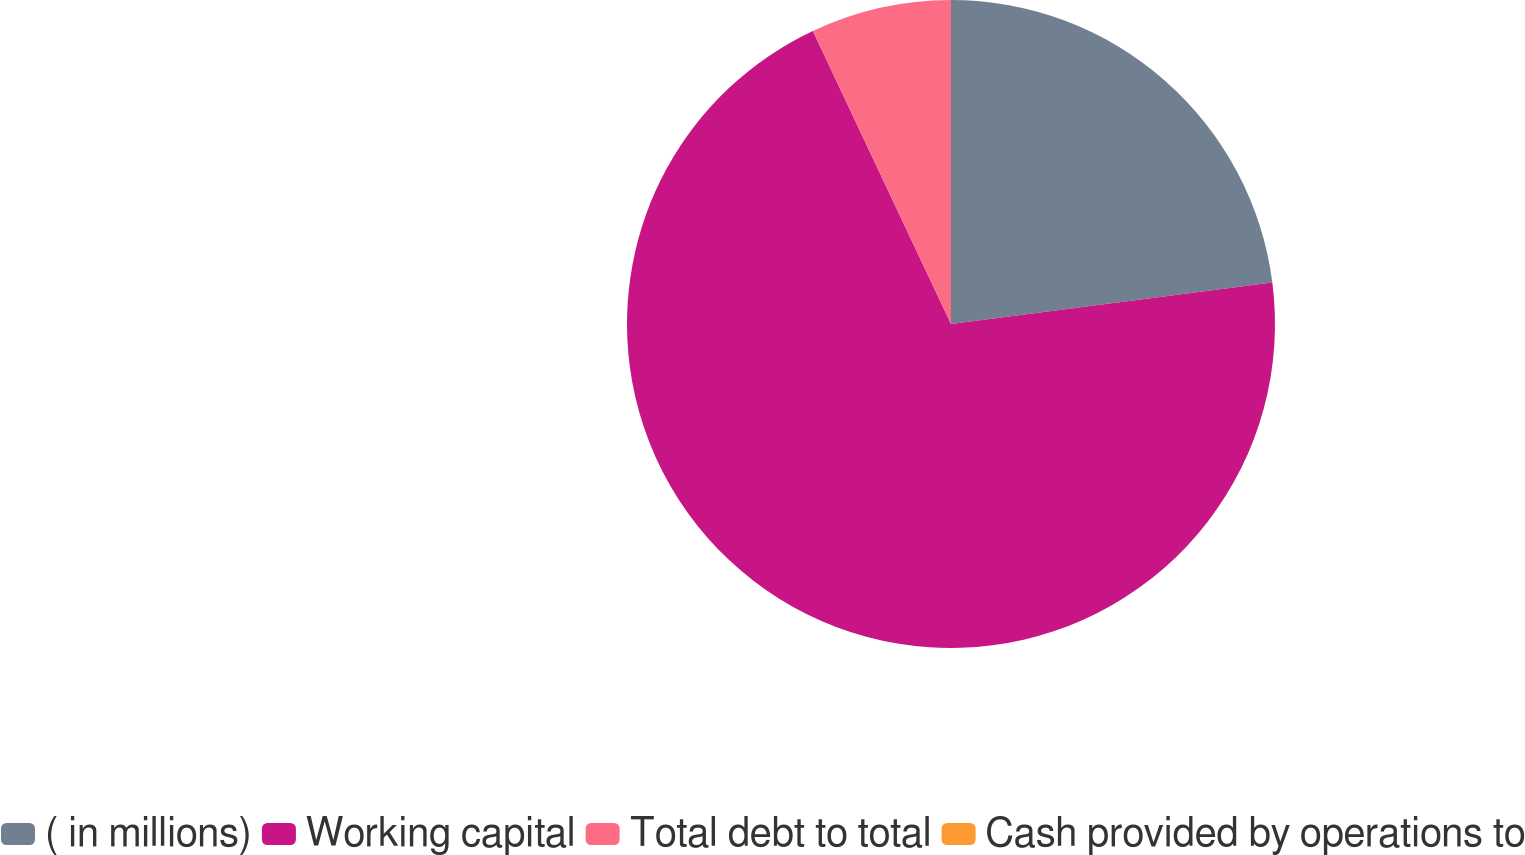<chart> <loc_0><loc_0><loc_500><loc_500><pie_chart><fcel>( in millions)<fcel>Working capital<fcel>Total debt to total<fcel>Cash provided by operations to<nl><fcel>22.96%<fcel>70.03%<fcel>7.01%<fcel>0.0%<nl></chart> 